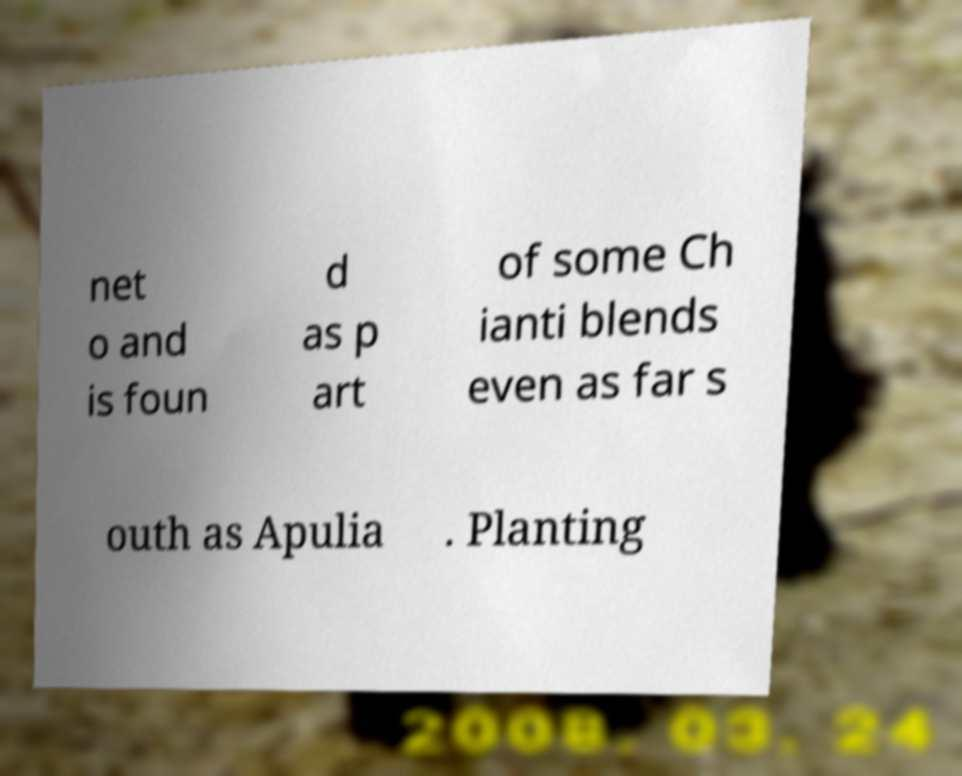I need the written content from this picture converted into text. Can you do that? net o and is foun d as p art of some Ch ianti blends even as far s outh as Apulia . Planting 